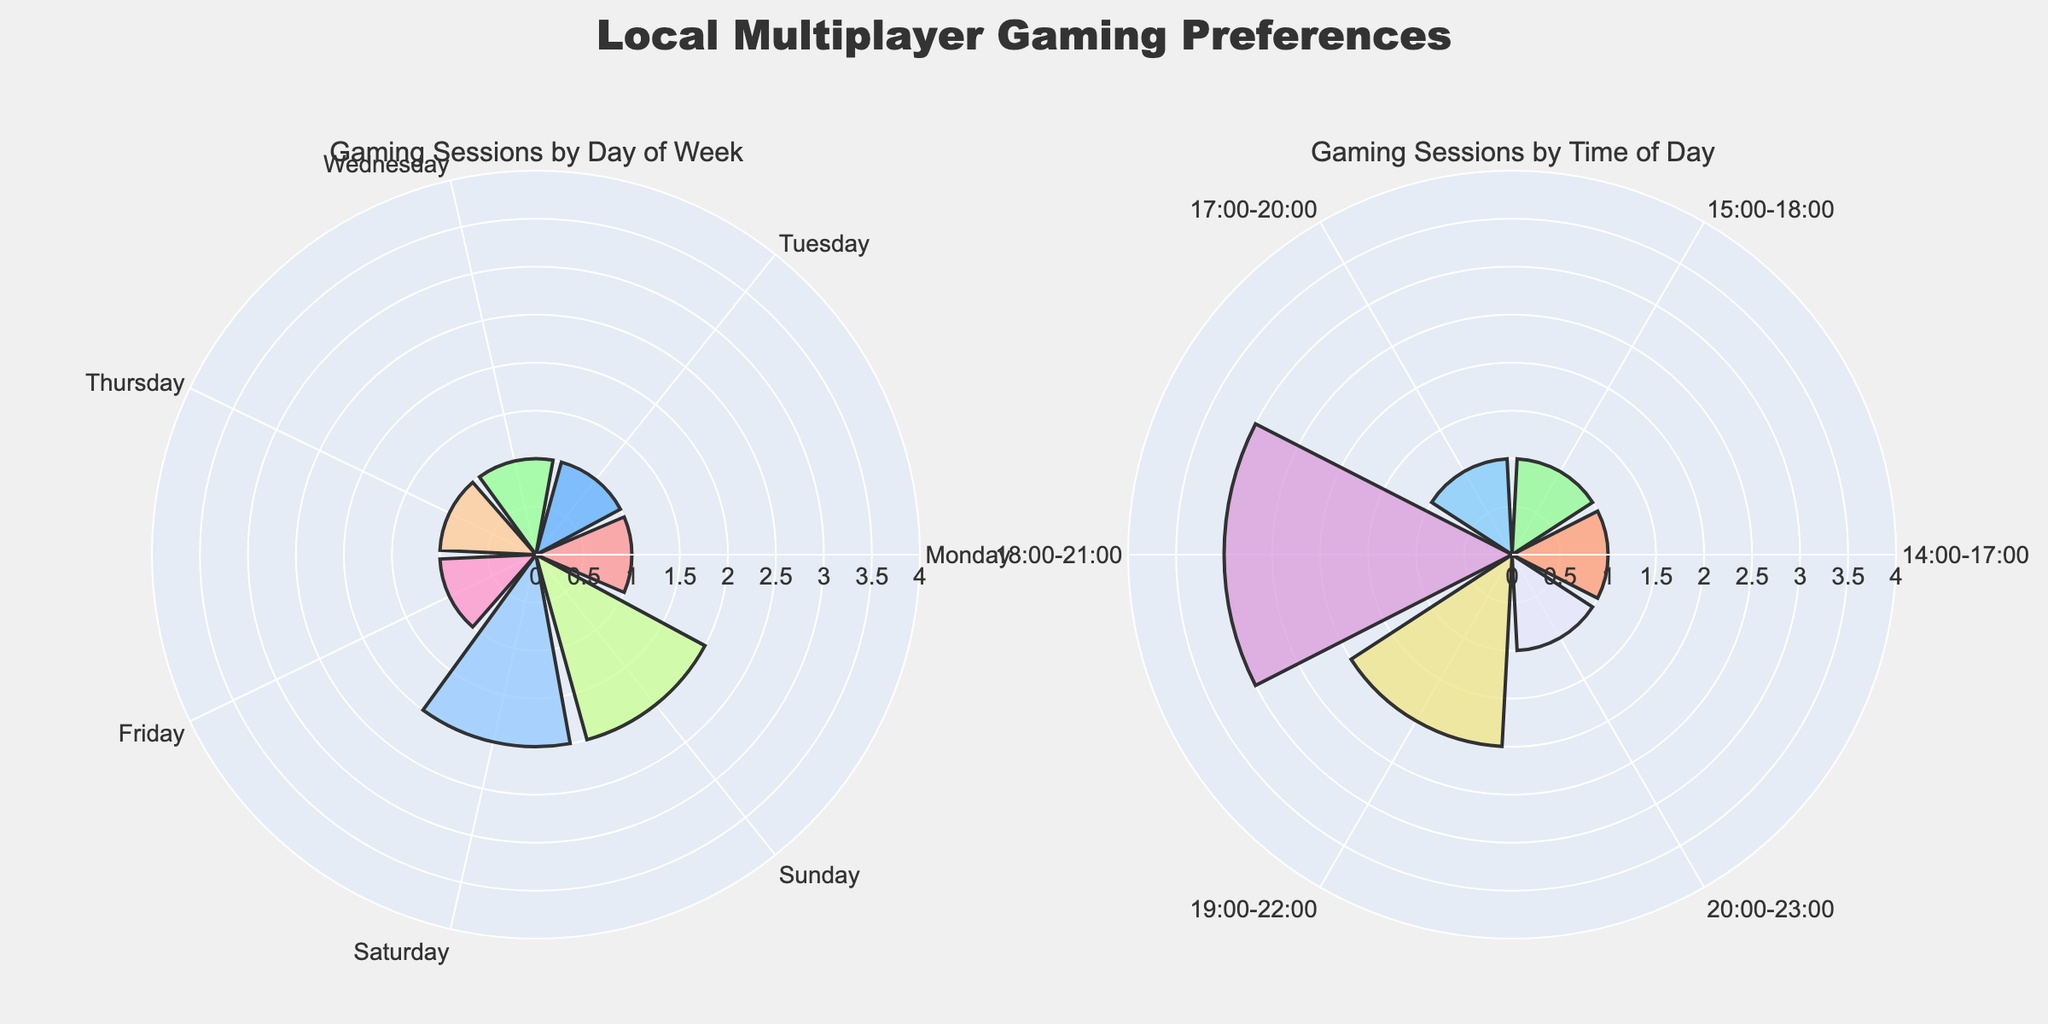Which day has the highest number of gaming sessions? The rose chart on the left shows the frequency of gaming sessions by day of the week. By examining the bars, Sunday sticks out as the day with the highest number of sessions.
Answer: Sunday How many gaming sessions occur on weekdays versus weekends? Sum the counts of gaming sessions from Monday to Friday (weekdays) and compare that to the sum for Saturday and Sunday (weekends). From the left chart: there are 4 on Monday, 3 on Tuesday, 5 on Wednesday, 6 on Thursday, and 7 on Friday, totaling 25 for weekdays. For weekends, there are 18 on Saturday and 17 on Sunday, totaling 35.
Answer: 25 weekdays, 35 weekends Which time of day has the highest gaming session frequency? The right side of the rose chart indicates the frequency of sessions by time ranges. The range "19:00-22:00" has the longest bar, signifying the highest frequency.
Answer: 19:00-22:00 How does the number of sessions on Saturday compare to those on Thursday? Using the left chart, we see that Saturday has 2 time ranges (15:00-18:00 and 19:00-22:00) totaling (8 + 10 = 18) sessions. Thursday has 1 session range (18:00-21:00) totaling 6 sessions. Therefore, Saturday has 12 more sessions than Thursday.
Answer: 12 more on Saturday What is the most popular time slot for gaming sessions on weekends? The right chart shows the time distribution. "19:00-22:00" is the most frequent time slot for both weekend days (Saturday and Sunday combined).
Answer: 19:00-22:00 On average, how many sessions occur per day? Divide the total number of sessions across all days by 7 (the number of days). In total, there are 60 sessions. Calculation: 60/7 ≈ 8.57.
Answer: About 8.57 Which day has the least number of gaming sessions? From the left chart, Tuesday has the shortest bar, indicating the least number of gaming sessions.
Answer: Tuesday Which time interval has the least number of gaming sessions and how many? Observing the right chart, "20:00-23:00" and "14:00-17:00" both show the shortest bars, each having 1 session.
Answer: 2 intervals, 1 session each 